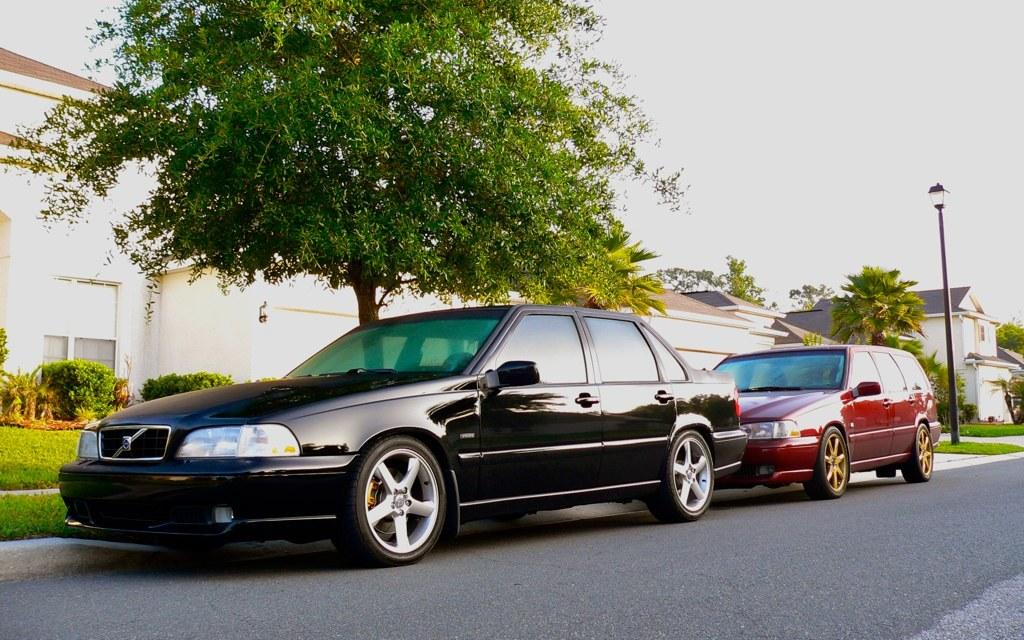What type of vehicles can be seen in the image? There are cars in the image. What natural elements are present in the image? There are trees, grass, and bushes in the image. What man-made structures are visible in the image? There are buildings, a street pole, and a street light in the image. What type of surface can be seen in the image? There is a road in the image. What part of the natural environment is visible in the image? The sky is visible in the image. What type of bread is being served at the sister's birthday party in the image? There is no mention of a sister or a birthday party in the image, and no bread is visible. 